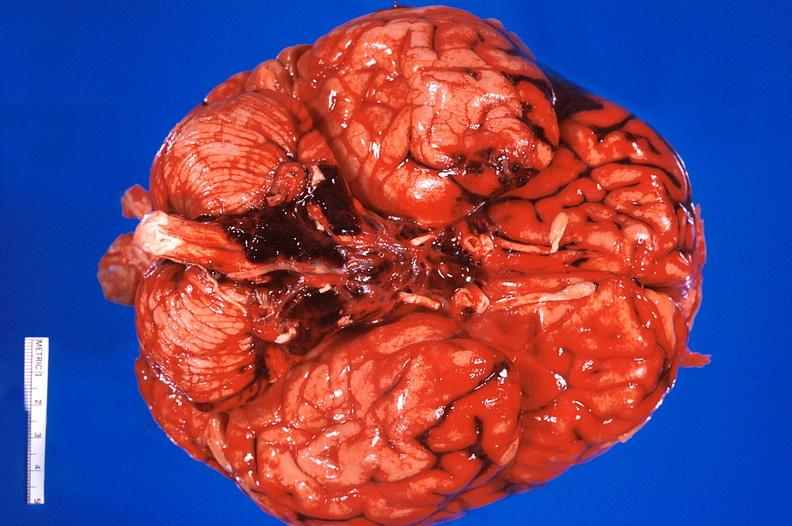what does this image show?
Answer the question using a single word or phrase. Brain 